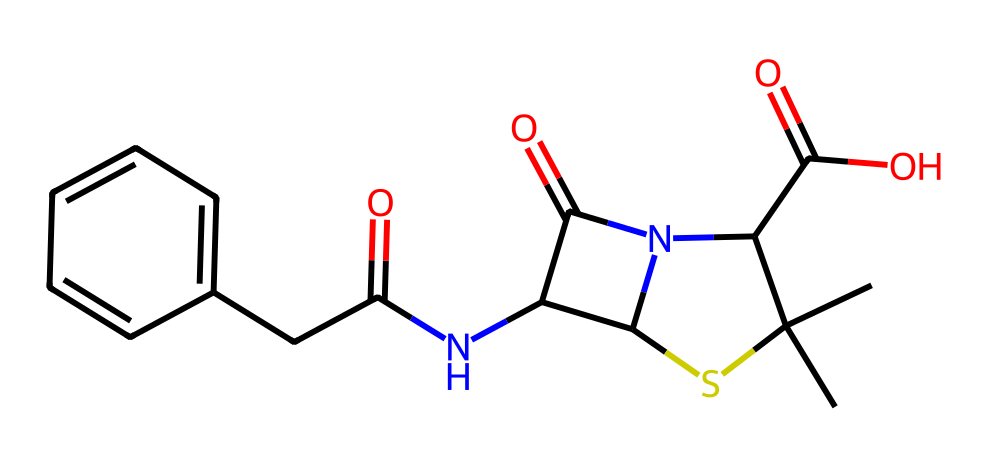How many carbon atoms are present in this compound? By analyzing the SMILES representation, we can count the number of carbon (C) symbols. There are a total of 9 carbon atoms represented in the structure.
Answer: 9 What type of bond connects the carbon atoms in this structure? In the provided SMILES, the presence of no explicit symbols for double or triple bonds between the carbon atoms suggests that the carbon atoms primarily share single bonds, although some carbon-carbon double bonds may exist due to the functional groups.
Answer: single Which functional group is primarily responsible for this compound’s antibacterial properties? The β-lactam ring is a characteristic feature in penicillin that is crucial for its antibacterial activity, allowing it to inhibit bacterial cell wall synthesis.
Answer: β-lactam What is the overall charge of this molecule at physiological pH? Examining the structure, specifically the carboxylic acid group and the amines, we determine that the compound is zwitterionic at physiological pH, indicating it carries both positive and negative charges but is overall neutral.
Answer: neutral How many nitrogen atoms are in this chemical structure? By counting the number of nitrogen (N) symbols in the SMILES representation, we find that there are 3 nitrogen atoms present in the compound.
Answer: 3 What is the main type of compound this structure represents? Given its structure and function, the molecule is classified as a beta-lactam antibiotic, which is a specific type of medicinal compound used in treating bacterial infections.
Answer: antibiotic 